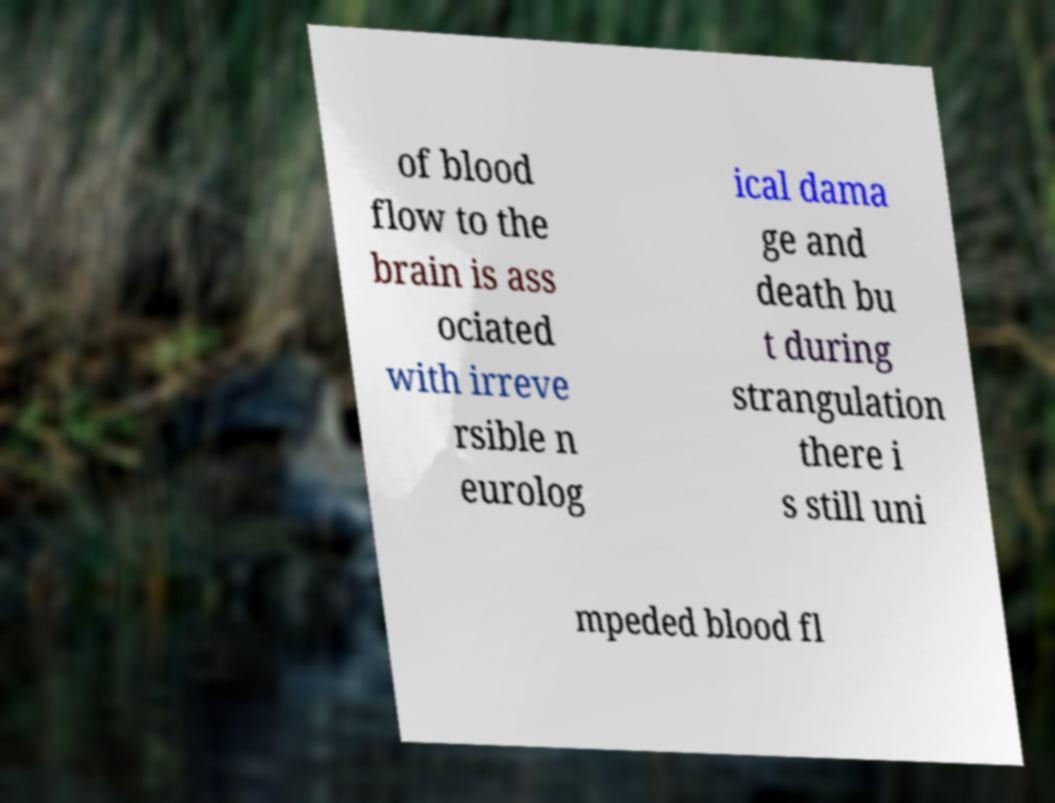I need the written content from this picture converted into text. Can you do that? of blood flow to the brain is ass ociated with irreve rsible n eurolog ical dama ge and death bu t during strangulation there i s still uni mpeded blood fl 